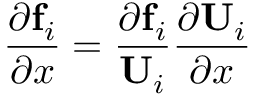<formula> <loc_0><loc_0><loc_500><loc_500>\frac { \partial f _ { i } } { \partial x } = \frac { \partial f _ { i } } { U _ { i } } \frac { \partial U _ { i } } { \partial x }</formula> 